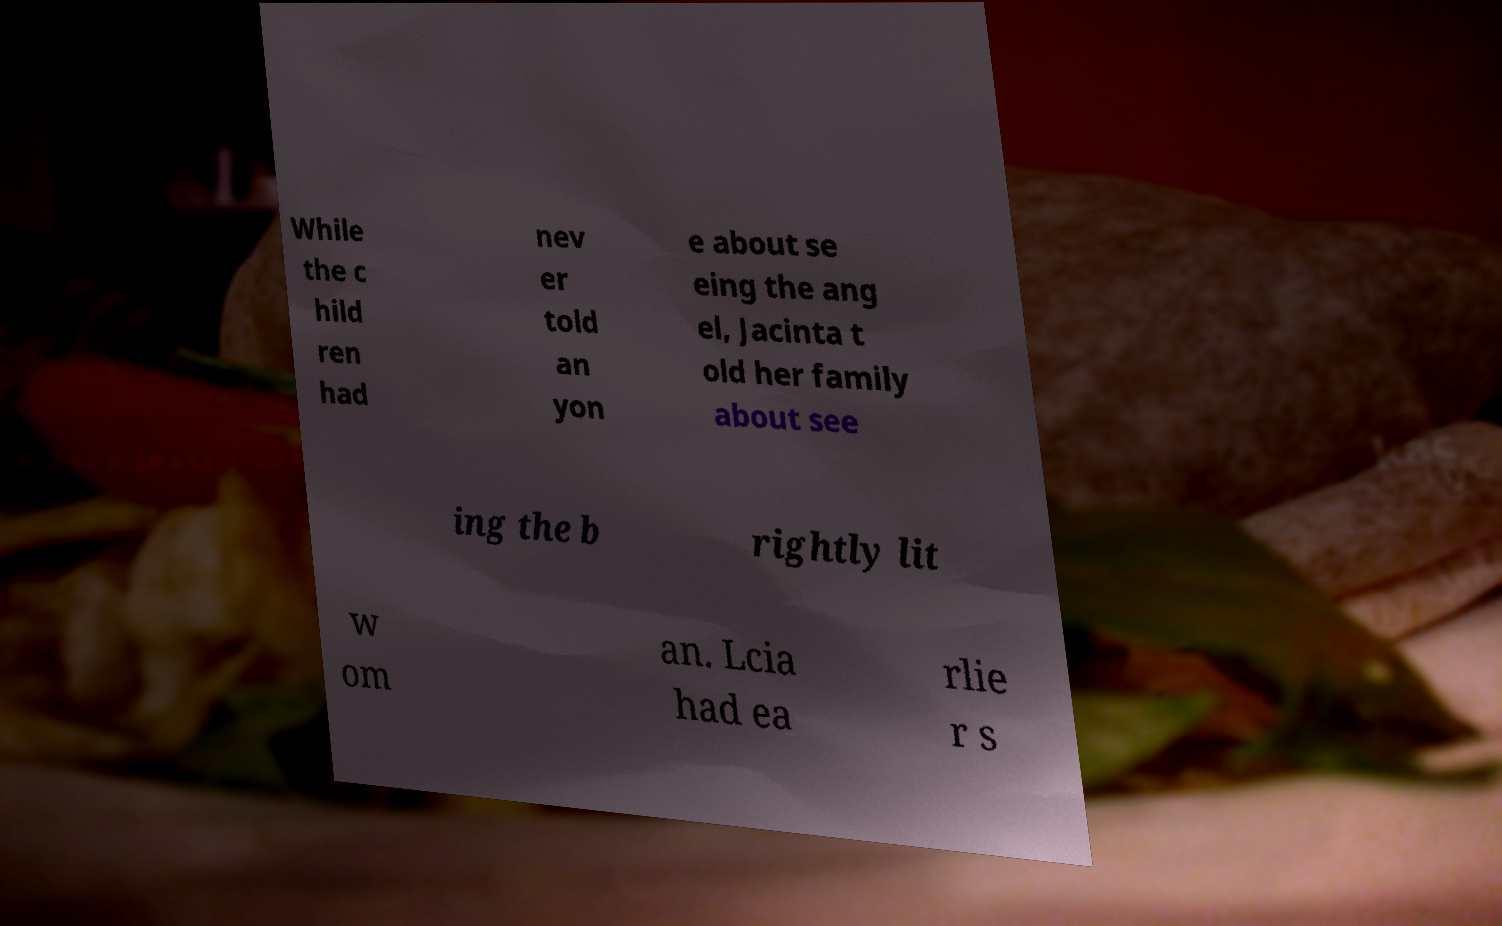I need the written content from this picture converted into text. Can you do that? While the c hild ren had nev er told an yon e about se eing the ang el, Jacinta t old her family about see ing the b rightly lit w om an. Lcia had ea rlie r s 